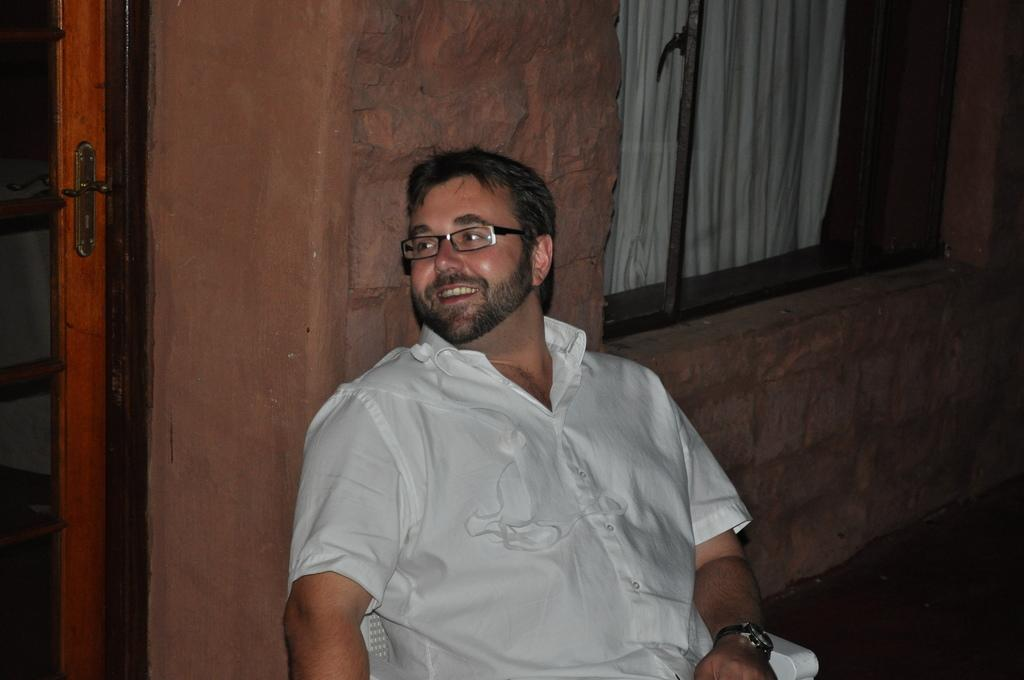What is the person in the image doing? The person is sitting in the chair in the image. Can you describe the person's appearance? The person is wearing glasses. What can be seen in the background of the image? There is a door, a window with a curtain, and a wall visible in the background. What type of bean is being served in the image? There is no bean present in the image. How many trucks can be seen in the image? There are no trucks visible in the image. 